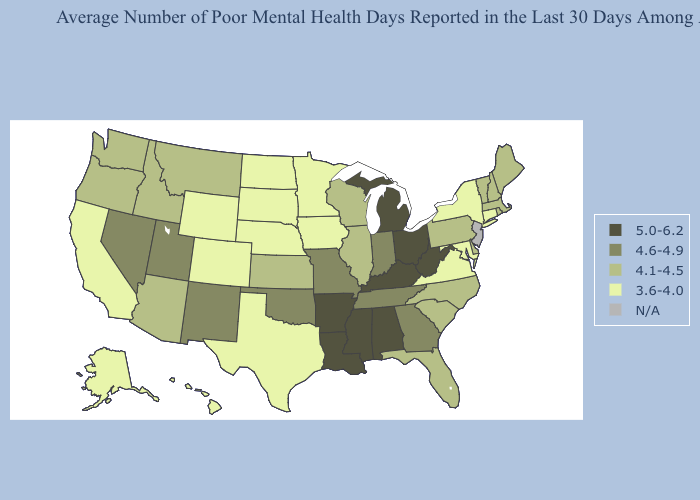Which states have the lowest value in the South?
Be succinct. Maryland, Texas, Virginia. Does Pennsylvania have the highest value in the Northeast?
Short answer required. Yes. What is the highest value in the USA?
Write a very short answer. 5.0-6.2. What is the value of West Virginia?
Keep it brief. 5.0-6.2. What is the value of Virginia?
Quick response, please. 3.6-4.0. Among the states that border Iowa , which have the highest value?
Be succinct. Missouri. Does the first symbol in the legend represent the smallest category?
Give a very brief answer. No. Name the states that have a value in the range 5.0-6.2?
Answer briefly. Alabama, Arkansas, Kentucky, Louisiana, Michigan, Mississippi, Ohio, West Virginia. Does Missouri have the lowest value in the USA?
Answer briefly. No. Name the states that have a value in the range 5.0-6.2?
Answer briefly. Alabama, Arkansas, Kentucky, Louisiana, Michigan, Mississippi, Ohio, West Virginia. Does the first symbol in the legend represent the smallest category?
Give a very brief answer. No. How many symbols are there in the legend?
Concise answer only. 5. Name the states that have a value in the range N/A?
Be succinct. New Jersey. Does Michigan have the highest value in the USA?
Keep it brief. Yes. 